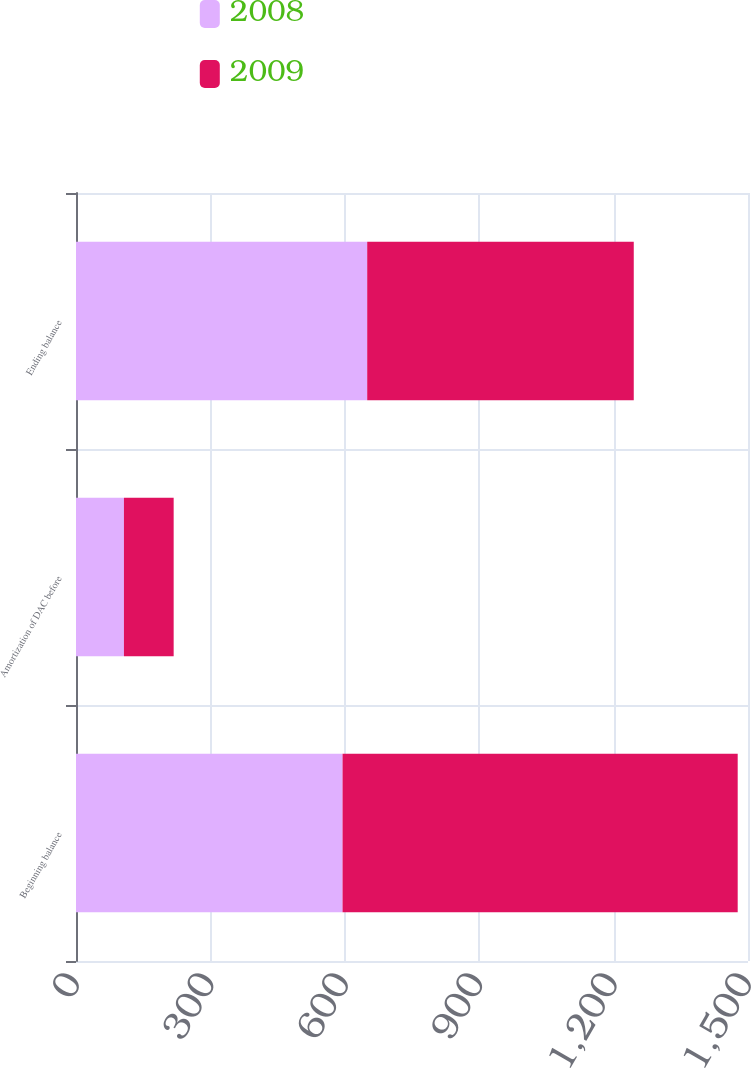Convert chart to OTSL. <chart><loc_0><loc_0><loc_500><loc_500><stacked_bar_chart><ecel><fcel>Beginning balance<fcel>Amortization of DAC before<fcel>Ending balance<nl><fcel>2008<fcel>595<fcel>107<fcel>650<nl><fcel>2009<fcel>882<fcel>111<fcel>595<nl></chart> 